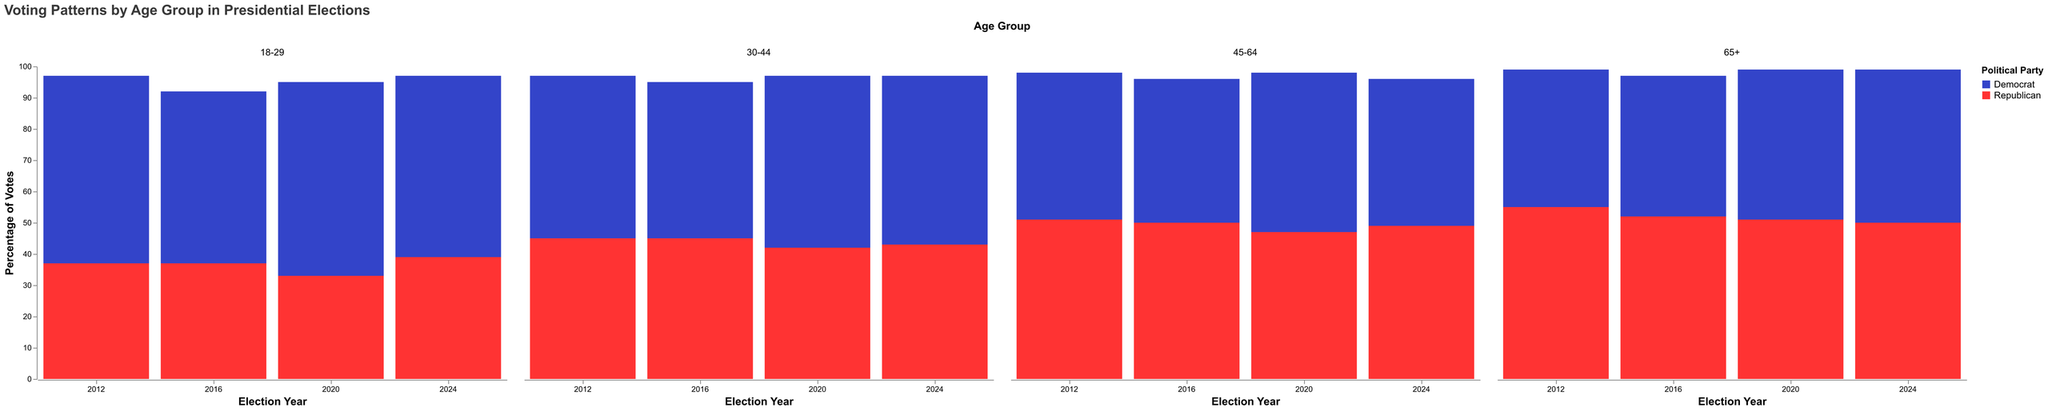What is the title of the figure? The title of a figure is located at the top and describes the overall topic of the visualization. For this figure, the title is written as "Voting Patterns by Age Group in Presidential Elections".
Answer: Voting Patterns by Age Group in Presidential Elections Which party had a higher percentage of votes in the 18-29 age group in 2020? Look at the section of the figure categorized by the 18-29 age group for the year 2020. Compare the heights of the bars colored for Democrats and Republicans. The bar for Democrats is higher.
Answer: Democrat What is the average percentage of votes the Democratic Party received in the 30-44 age group across all years shown? Identify the percentage of votes the Democratic Party received in the 30-44 age group for each year (52 for 2012, 50 for 2016, 55 for 2020, and 54 for 2024). Sum these numbers and divide by the number of data points, which is 4. Average = (52+50+55+54)/4 = 211/4.
Answer: 52.75 How did the voting pattern for the Democratic Party in the 65+ age group change from 2012 to 2024? Compare the percentage of votes for Democrats in the 65+ age group across the years 2012, 2016, 2020, and 2024. The values are 44, 45, 48, and 49 respectively.
Answer: Increased Which year saw the largest percentage of votes for the Republican Party in the 45-64 age group? Analyze the 45-64 age group section and compare the bars representing the Republican Party for each year. The highest is in 2012 at 51 percent.
Answer: 2012 Did the Democratic Party receive more votes than the Republican Party in the 30-44 age group in 2016? Compare the heights of the bars for Democrats and Republicans in the 30-44 age group for the year 2016. Democrats received 50 percent and Republicans received 45 percent.
Answer: Yes What is the smallest percentage of votes the Republican Party received in any age group across all years? Look for the minimum value represented by the bars for the Republican Party across all age groups and years. The smallest percentage is 33 percent in the 18-29 age group in 2020.
Answer: 33 percent In which age group and year did the Democratic Party receive its highest percentage of votes? Find the highest bar representing the Democratic Party across all age groups and years. The highest percentage is 62 percent in the 18-29 age group in 2020.
Answer: 18-29 in 2020 What is the difference in percentage of votes between Democrats and Republicans in the 45-64 age group in 2012? Identify the percentages for Democrats (47) and Republicans (51) in the 45-64 age group for 2012 and calculate the difference. Difference = 51 - 47 = 4.
Answer: 4 Which age group shows the smallest gap between Democratic and Republican votes in 2024? Compare the difference between percentages of Democratic and Republican votes for each age group in 2024. The smallest gap is in the 65+ age group with a difference of 1 (49 versus 50).
Answer: 65+ 